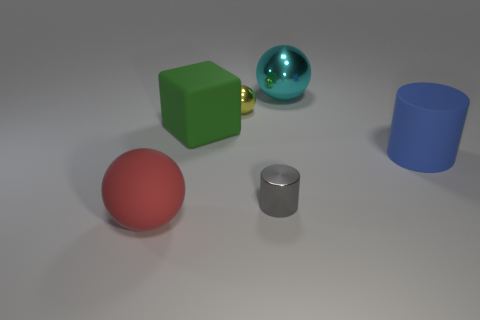What can you tell me about the lighting in this image? The lighting in the image is soft and diffused, casting gentle shadows on the ground beneath each object. The source of light seems to be coming from above, given how the shadows are angled, suggesting an indoor setting with a ceiling light or overhead softbox lighting commonly used in photography. 